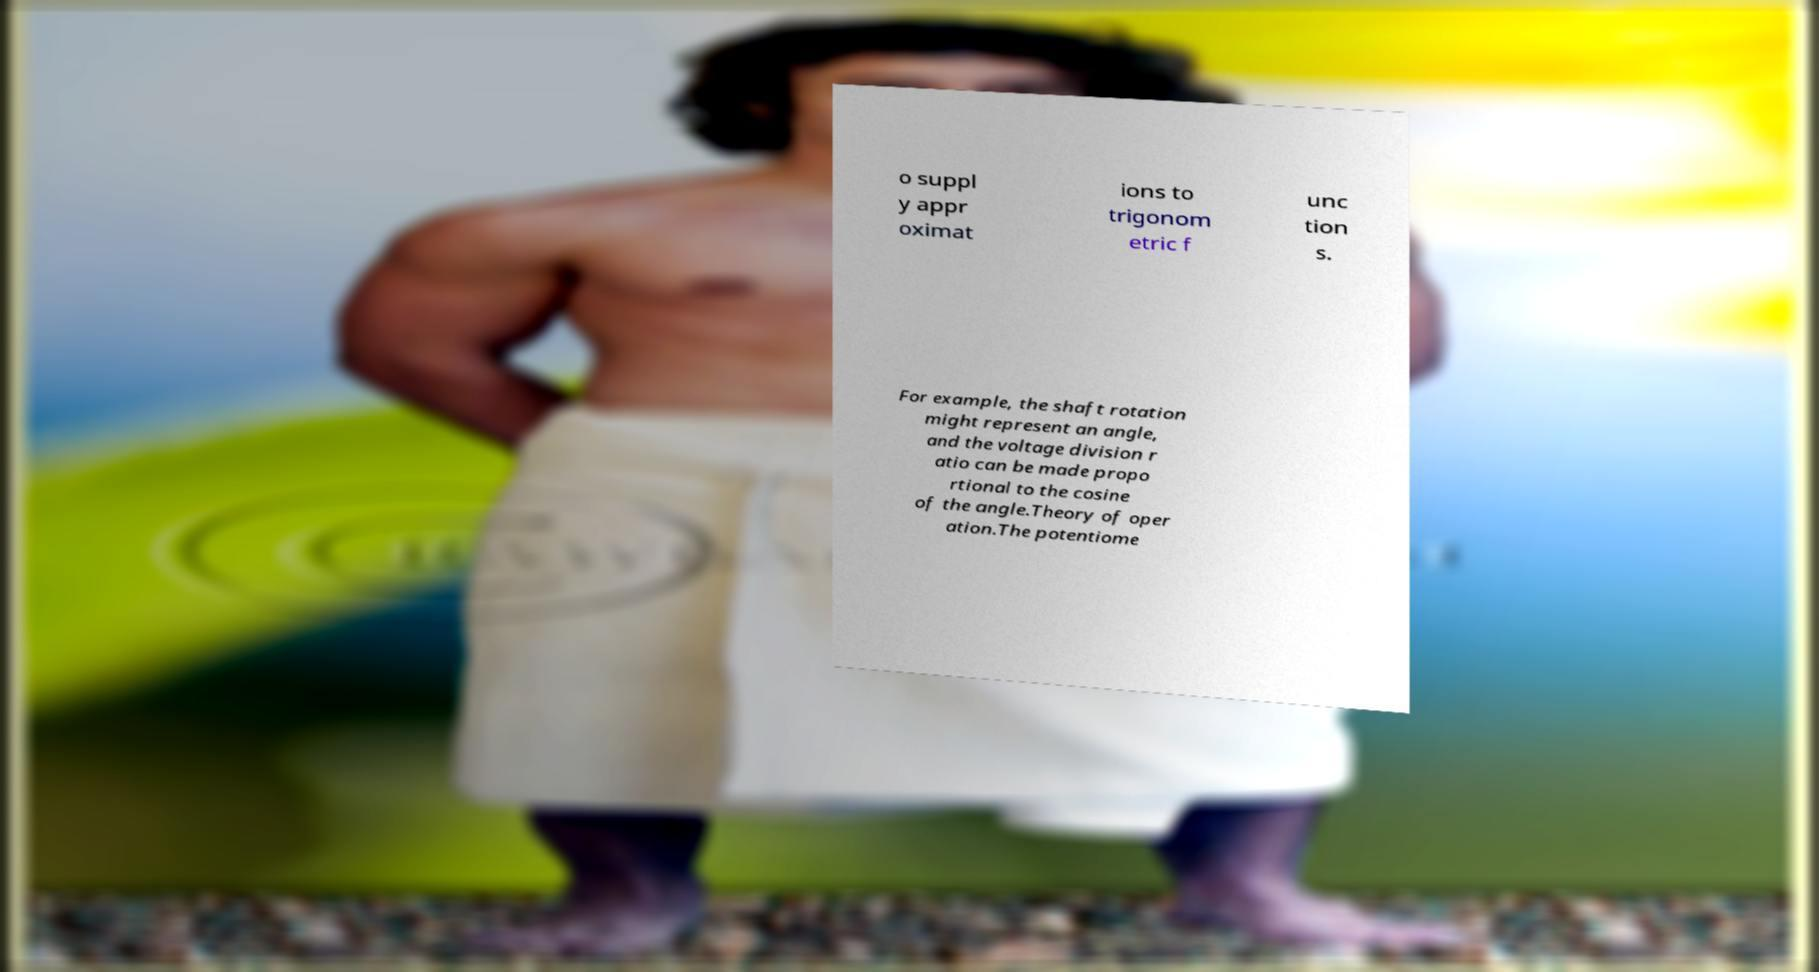There's text embedded in this image that I need extracted. Can you transcribe it verbatim? o suppl y appr oximat ions to trigonom etric f unc tion s. For example, the shaft rotation might represent an angle, and the voltage division r atio can be made propo rtional to the cosine of the angle.Theory of oper ation.The potentiome 